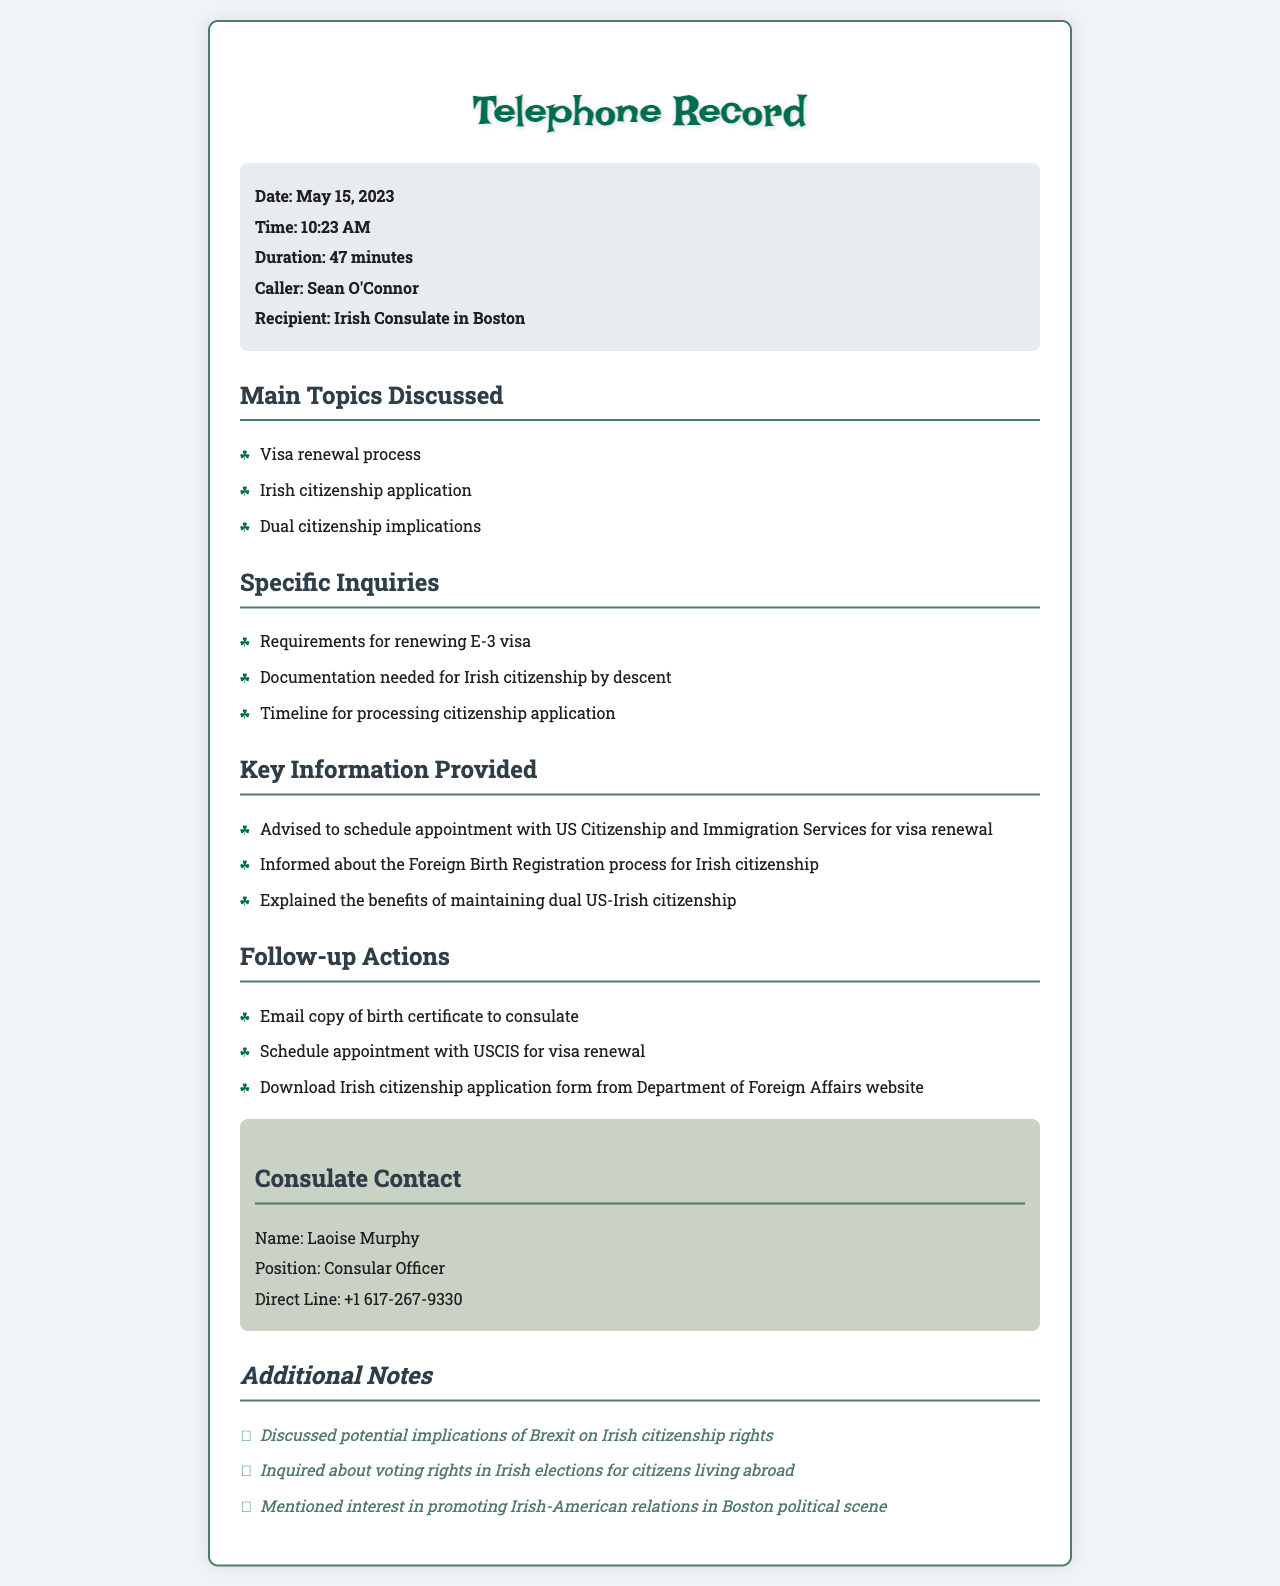What is the date of the call? The date of the call is indicated in the document as "May 15, 2023".
Answer: May 15, 2023 Who was the caller? The document states that the caller's name is "Sean O'Connor".
Answer: Sean O'Connor What was the duration of the phone call? The duration of the call is explicitly mentioned in the document as "47 minutes".
Answer: 47 minutes Which consulate was contacted? The document specifies that the recipient of the call was the "Irish Consulate in Boston".
Answer: Irish Consulate in Boston What was discussed as a requirement for renewing the visa? The document mentions that the caller was advised to schedule an appointment with USCIS for visa renewal, indicating a requirement.
Answer: Schedule appointment with USCIS What are the benefits mentioned for maintaining dual citizenship? The document states that the benefits of maintaining dual US-Irish citizenship were explained but does not provide specific details.
Answer: Benefits of dual citizenship What action is to be taken regarding the birth certificate? According to the document, the follow-up action is to "Email copy of birth certificate to consulate".
Answer: Email copy of birth certificate Who is the consular officer mentioned in the document? The document lists "Laoise Murphy" as the consular officer.
Answer: Laoise Murphy What additional topic related to citizenship rights was discussed? The document notes a discussion about the "potential implications of Brexit on Irish citizenship rights".
Answer: Brexit implications What interest did the caller mention about local politics? The document indicates the caller mentioned "interest in promoting Irish-American relations in Boston political scene".
Answer: Promoting Irish-American relations 